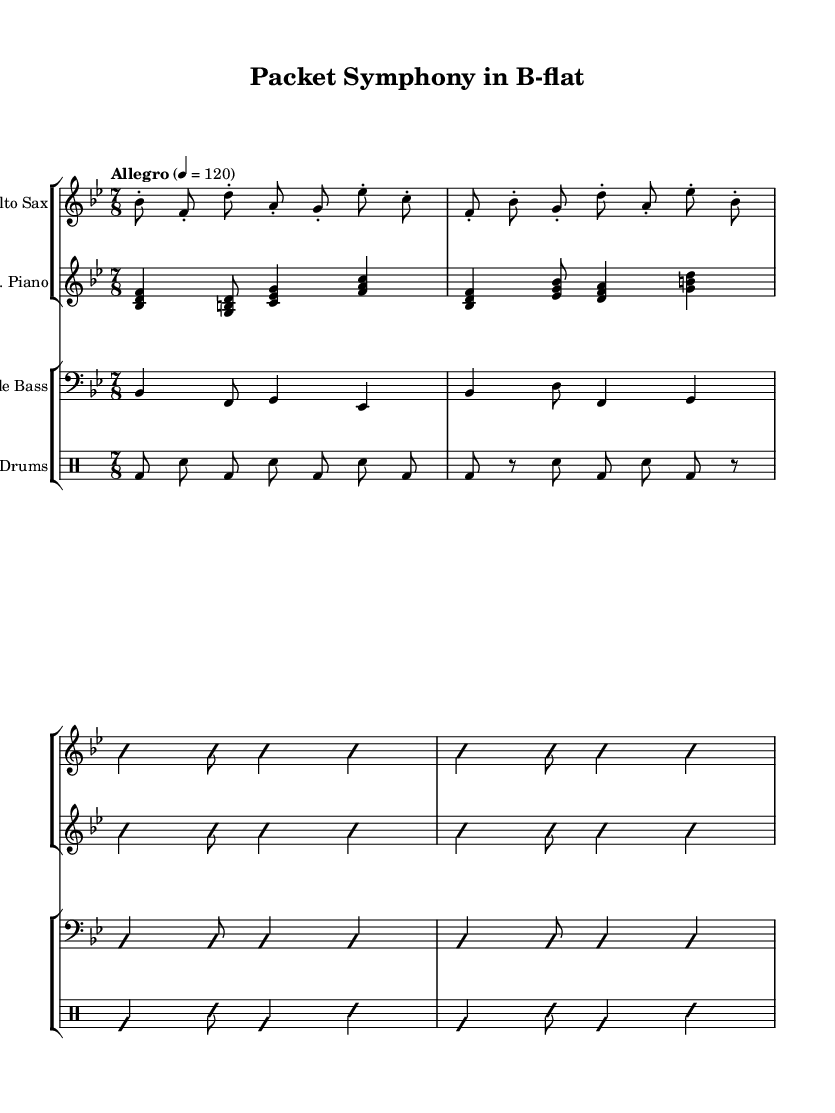What is the key signature of this music? The key signature indicates that the music is in B-flat major, as it has two flats shown in the key signature area.
Answer: B-flat major What is the time signature of this piece? The time signature is displayed at the beginning of the score, showing a 7 over 8, meaning there are seven eighth notes per measure.
Answer: 7/8 What is the tempo marking for this composition? The tempo marking is specified in the score, indicating "Allegro" with a metronome marking of 120 beats per minute.
Answer: Allegro, 120 Which instrument has the melody line predominantly? The alto saxophone is featured prominently at the start, playing the initial phrases that define the theme of the composition.
Answer: Alto Sax How many measures are there in the saxophone part before improvisation begins? By counting the measures shown in the saxophone part before the improvisation indication, there are four measures before it.
Answer: 4 What kind of rhythmic elements are used in the drum part? The drum part uses a combination of bass drum and snare drum patterns, creating a distinct rhythmic feel typical in jazz for a steady groove.
Answer: Bass and snare Explain the nature of improvisation indicated in the score. Improvisation is signified by the markings "improvisationOn" and "improvisationOff," suggesting that players are invited to create spontaneous music during these sections, common in jazz culture.
Answer: Spontaneous sections 